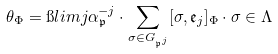Convert formula to latex. <formula><loc_0><loc_0><loc_500><loc_500>\theta _ { \Phi } = \i l i m j \alpha _ { \mathfrak { p } } ^ { - j } \cdot \sum _ { \sigma \in G _ { \mathfrak { p } ^ { j } } } [ \sigma , \mathfrak { e } _ { j } ] _ { \Phi } \cdot \sigma \in \Lambda</formula> 